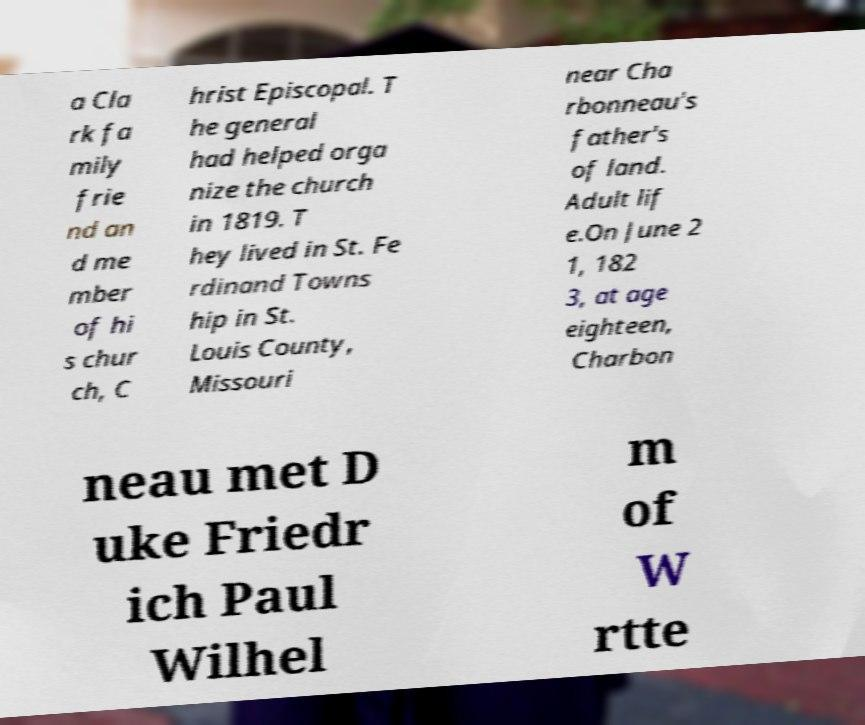Please read and relay the text visible in this image. What does it say? a Cla rk fa mily frie nd an d me mber of hi s chur ch, C hrist Episcopal. T he general had helped orga nize the church in 1819. T hey lived in St. Fe rdinand Towns hip in St. Louis County, Missouri near Cha rbonneau's father's of land. Adult lif e.On June 2 1, 182 3, at age eighteen, Charbon neau met D uke Friedr ich Paul Wilhel m of W rtte 